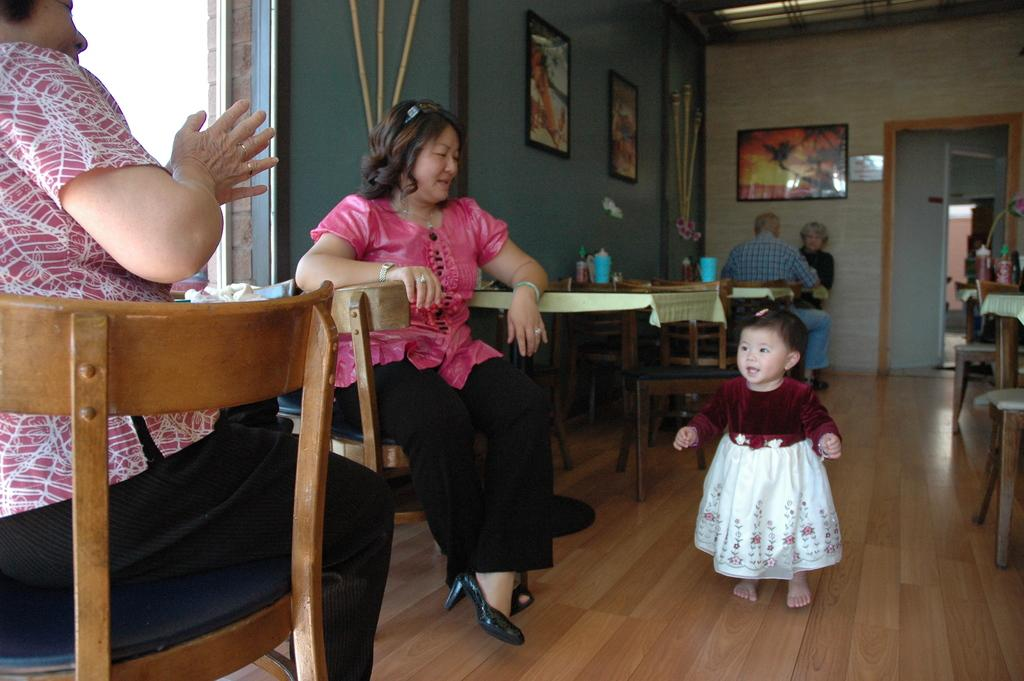How many women are in the image? There are two women in the image. What are the women doing in the image? The women are sitting on chairs. What can be seen in the hall where the women are sitting? There are tables present in the hall. What is in the middle of the image? There is a baby in the middle of the image. What is on the wall in the image? There are portraits on the wall. What is the income of the baby in the image? The image does not provide information about the baby's income, as it is not relevant to the content of the image. 